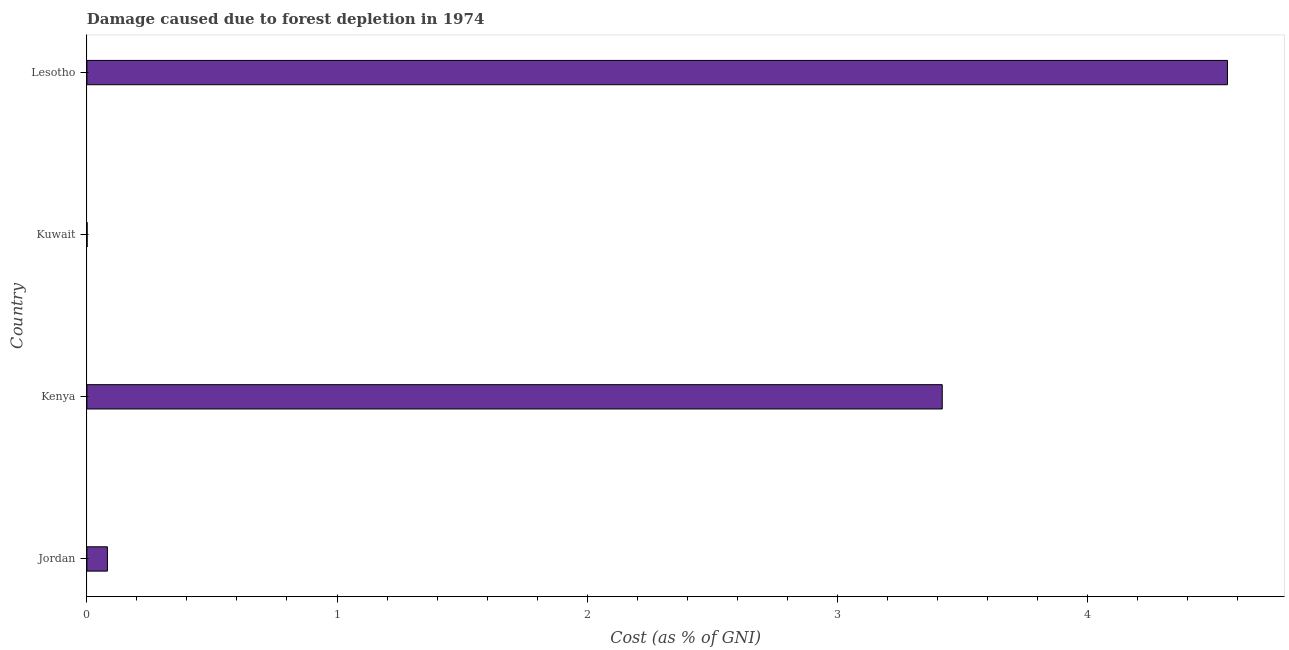Does the graph contain grids?
Provide a short and direct response. No. What is the title of the graph?
Ensure brevity in your answer.  Damage caused due to forest depletion in 1974. What is the label or title of the X-axis?
Give a very brief answer. Cost (as % of GNI). What is the label or title of the Y-axis?
Give a very brief answer. Country. What is the damage caused due to forest depletion in Lesotho?
Keep it short and to the point. 4.56. Across all countries, what is the maximum damage caused due to forest depletion?
Your answer should be compact. 4.56. Across all countries, what is the minimum damage caused due to forest depletion?
Give a very brief answer. 0. In which country was the damage caused due to forest depletion maximum?
Provide a short and direct response. Lesotho. In which country was the damage caused due to forest depletion minimum?
Ensure brevity in your answer.  Kuwait. What is the sum of the damage caused due to forest depletion?
Your answer should be compact. 8.06. What is the difference between the damage caused due to forest depletion in Kenya and Kuwait?
Offer a terse response. 3.42. What is the average damage caused due to forest depletion per country?
Offer a very short reply. 2.02. What is the median damage caused due to forest depletion?
Offer a very short reply. 1.75. In how many countries, is the damage caused due to forest depletion greater than 2.8 %?
Offer a very short reply. 2. What is the ratio of the damage caused due to forest depletion in Kenya to that in Lesotho?
Make the answer very short. 0.75. Is the damage caused due to forest depletion in Kuwait less than that in Lesotho?
Offer a terse response. Yes. Is the difference between the damage caused due to forest depletion in Kenya and Kuwait greater than the difference between any two countries?
Provide a short and direct response. No. What is the difference between the highest and the second highest damage caused due to forest depletion?
Keep it short and to the point. 1.14. Is the sum of the damage caused due to forest depletion in Kenya and Lesotho greater than the maximum damage caused due to forest depletion across all countries?
Provide a succinct answer. Yes. What is the difference between the highest and the lowest damage caused due to forest depletion?
Your response must be concise. 4.56. How many bars are there?
Your answer should be compact. 4. Are the values on the major ticks of X-axis written in scientific E-notation?
Make the answer very short. No. What is the Cost (as % of GNI) of Jordan?
Your response must be concise. 0.08. What is the Cost (as % of GNI) of Kenya?
Your response must be concise. 3.42. What is the Cost (as % of GNI) in Kuwait?
Provide a short and direct response. 0. What is the Cost (as % of GNI) of Lesotho?
Offer a very short reply. 4.56. What is the difference between the Cost (as % of GNI) in Jordan and Kenya?
Your answer should be compact. -3.34. What is the difference between the Cost (as % of GNI) in Jordan and Kuwait?
Keep it short and to the point. 0.08. What is the difference between the Cost (as % of GNI) in Jordan and Lesotho?
Provide a succinct answer. -4.48. What is the difference between the Cost (as % of GNI) in Kenya and Kuwait?
Provide a short and direct response. 3.42. What is the difference between the Cost (as % of GNI) in Kenya and Lesotho?
Your answer should be compact. -1.14. What is the difference between the Cost (as % of GNI) in Kuwait and Lesotho?
Provide a succinct answer. -4.56. What is the ratio of the Cost (as % of GNI) in Jordan to that in Kenya?
Provide a succinct answer. 0.02. What is the ratio of the Cost (as % of GNI) in Jordan to that in Kuwait?
Keep it short and to the point. 93.02. What is the ratio of the Cost (as % of GNI) in Jordan to that in Lesotho?
Offer a very short reply. 0.02. What is the ratio of the Cost (as % of GNI) in Kenya to that in Kuwait?
Give a very brief answer. 3877.7. What is the ratio of the Cost (as % of GNI) in Kuwait to that in Lesotho?
Ensure brevity in your answer.  0. 